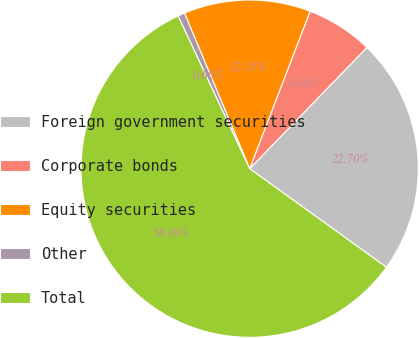Convert chart to OTSL. <chart><loc_0><loc_0><loc_500><loc_500><pie_chart><fcel>Foreign government securities<fcel>Corporate bonds<fcel>Equity securities<fcel>Other<fcel>Total<nl><fcel>22.7%<fcel>6.4%<fcel>12.15%<fcel>0.66%<fcel>58.08%<nl></chart> 